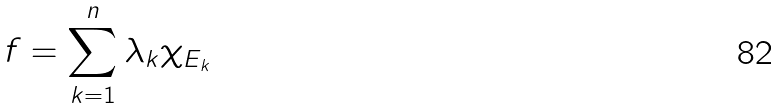<formula> <loc_0><loc_0><loc_500><loc_500>f = \sum _ { k = 1 } ^ { n } \lambda _ { k } \chi _ { E _ { k } }</formula> 